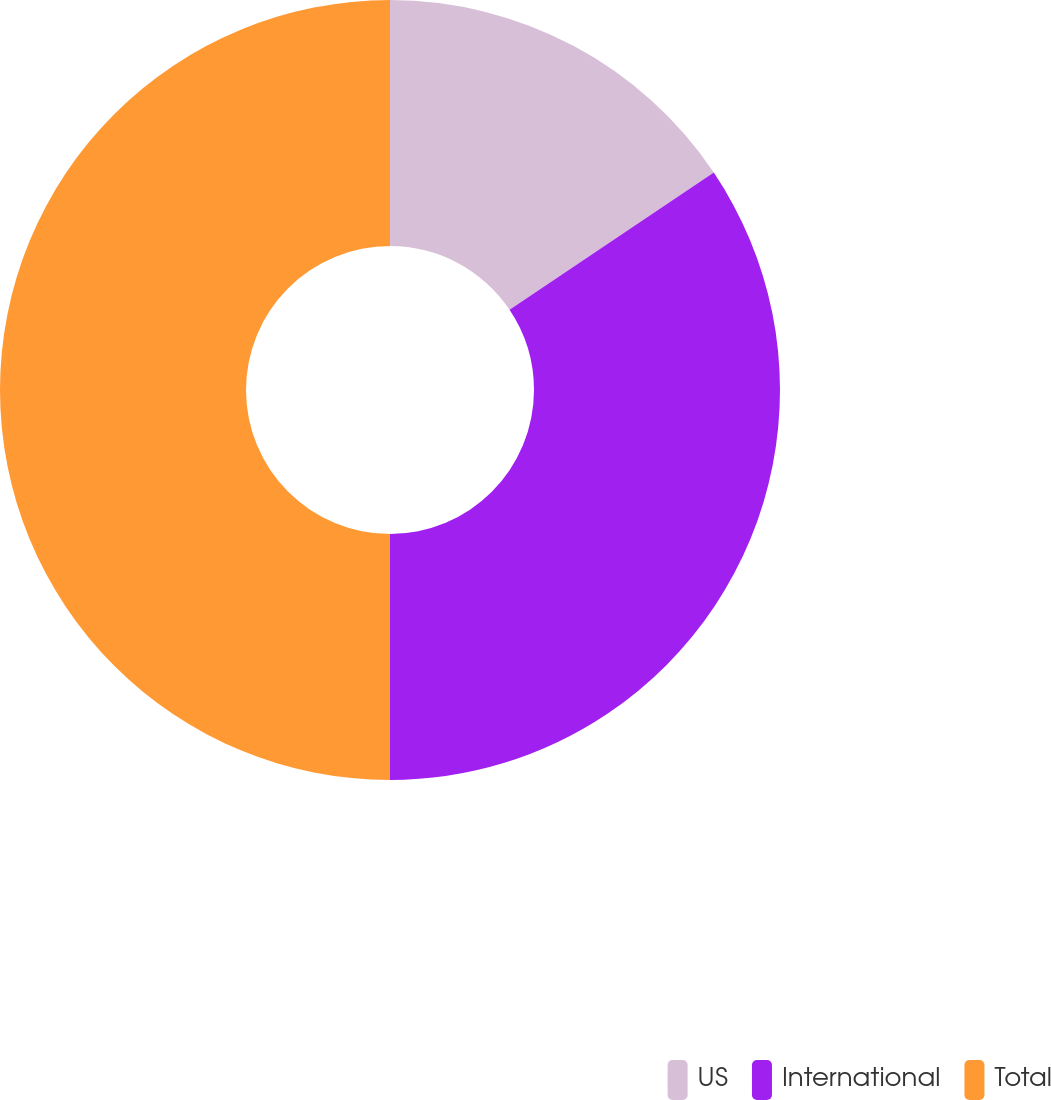Convert chart to OTSL. <chart><loc_0><loc_0><loc_500><loc_500><pie_chart><fcel>US<fcel>International<fcel>Total<nl><fcel>15.59%<fcel>34.41%<fcel>50.0%<nl></chart> 